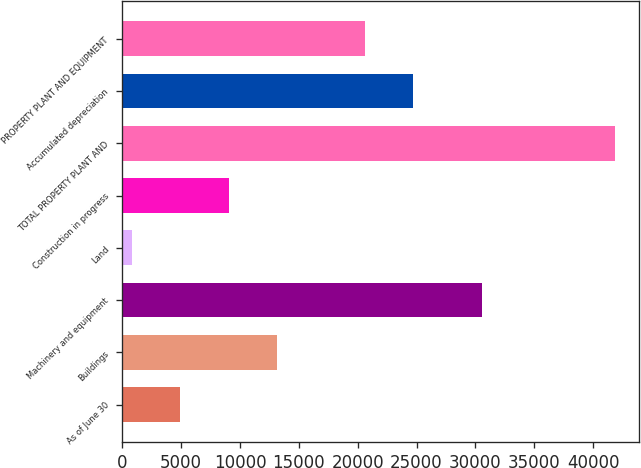Convert chart to OTSL. <chart><loc_0><loc_0><loc_500><loc_500><bar_chart><fcel>As of June 30<fcel>Buildings<fcel>Machinery and equipment<fcel>Land<fcel>Construction in progress<fcel>TOTAL PROPERTY PLANT AND<fcel>Accumulated depreciation<fcel>PROPERTY PLANT AND EQUIPMENT<nl><fcel>4941.6<fcel>13142.8<fcel>30595<fcel>841<fcel>9042.2<fcel>41847<fcel>24700.6<fcel>20600<nl></chart> 